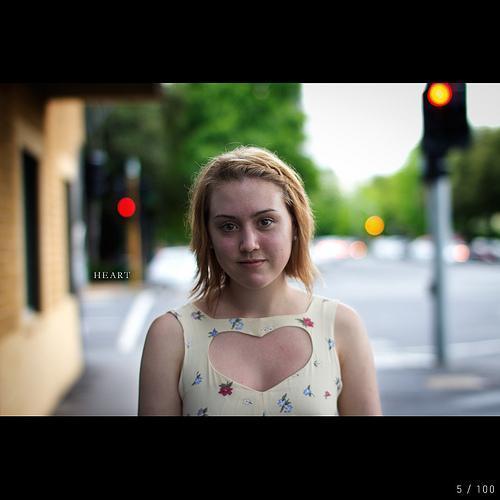How many people are in the photo?
Give a very brief answer. 1. 